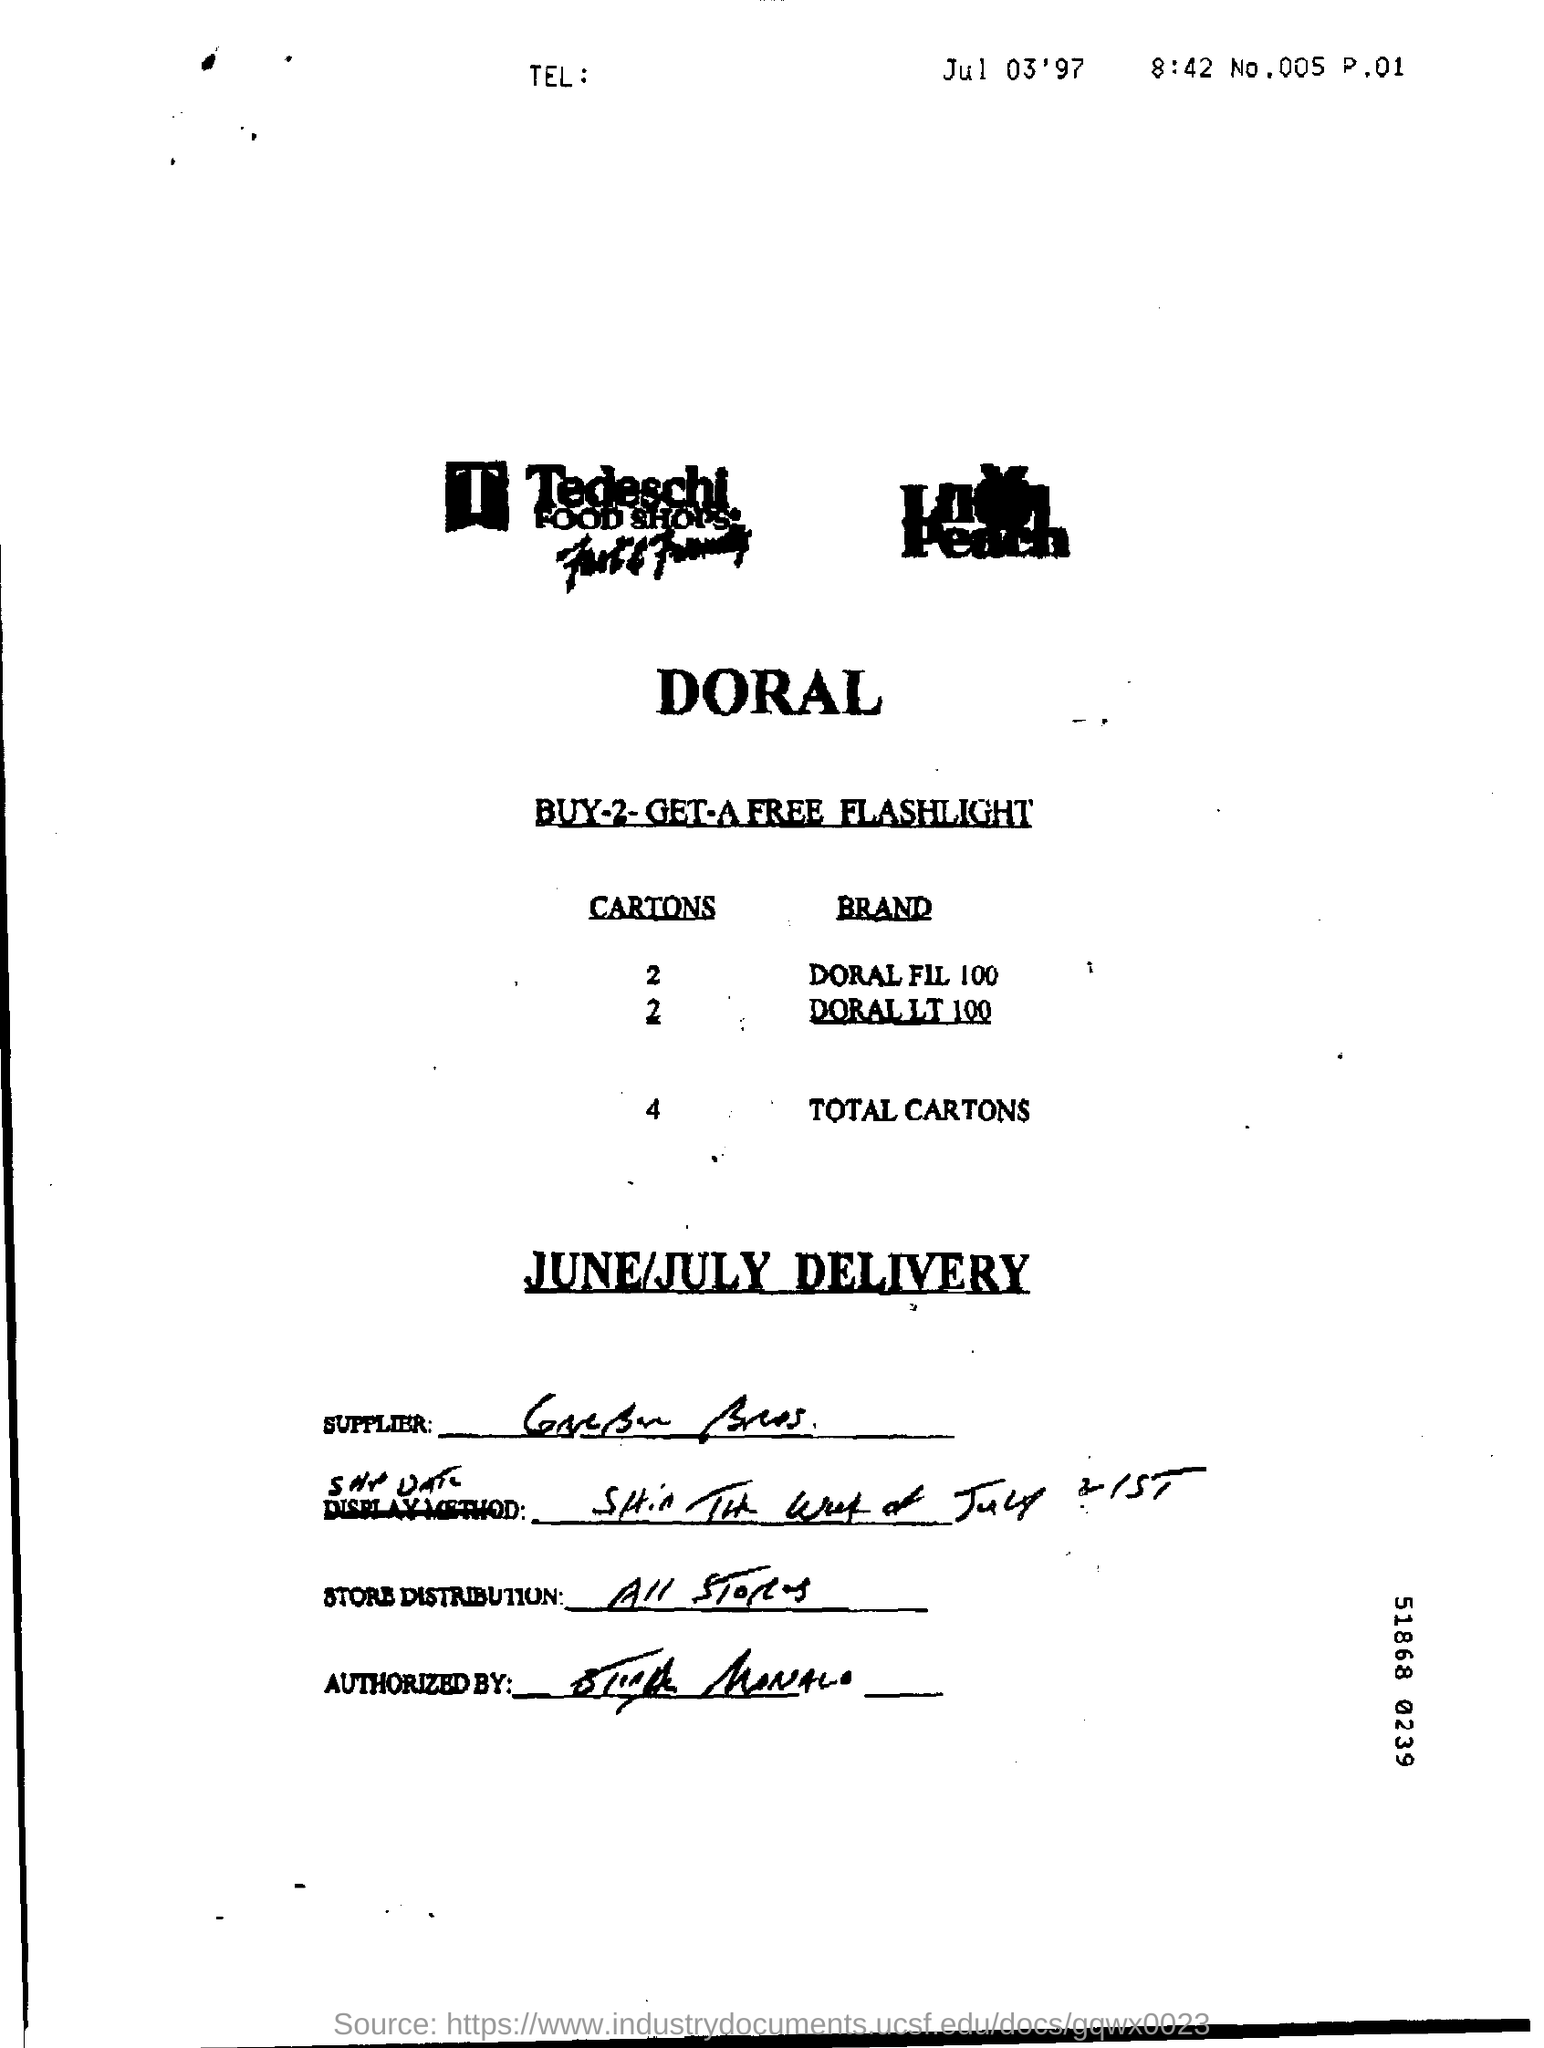How many Cartons in total of Doral FIL 100 and Doral LT 100?
Provide a succinct answer. 4. 